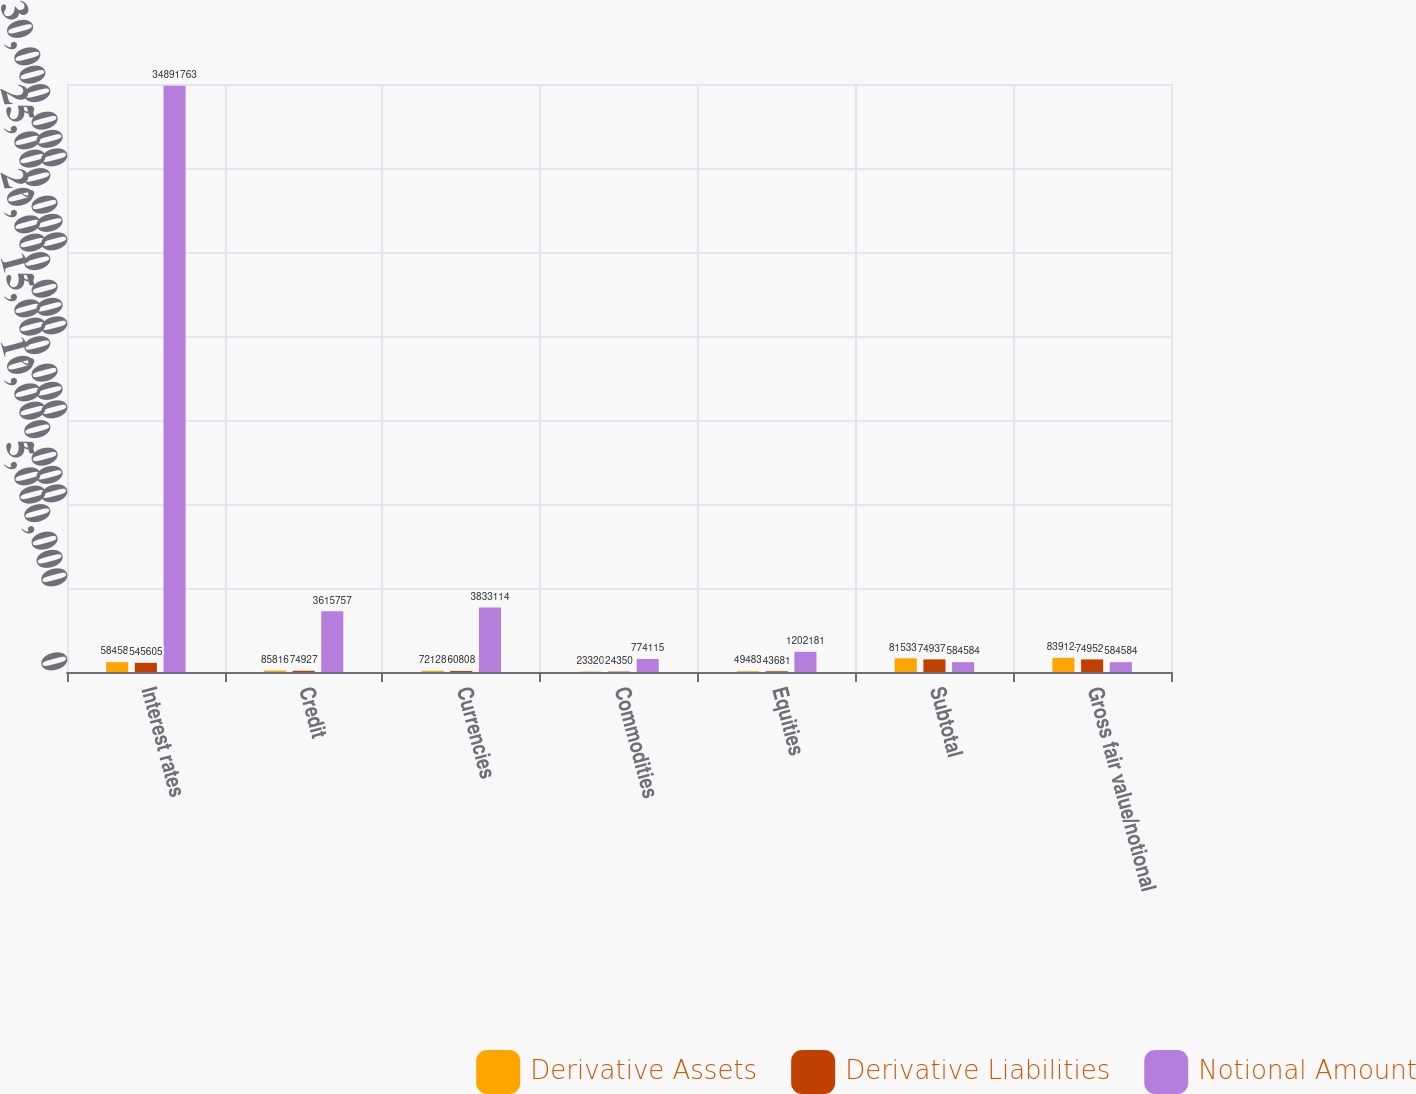Convert chart. <chart><loc_0><loc_0><loc_500><loc_500><stacked_bar_chart><ecel><fcel>Interest rates<fcel>Credit<fcel>Currencies<fcel>Commodities<fcel>Equities<fcel>Subtotal<fcel>Gross fair value/notional<nl><fcel>Derivative Assets<fcel>584584<fcel>85816<fcel>72128<fcel>23320<fcel>49483<fcel>815331<fcel>839124<nl><fcel>Derivative Liabilities<fcel>545605<fcel>74927<fcel>60808<fcel>24350<fcel>43681<fcel>749371<fcel>749523<nl><fcel>Notional Amount<fcel>3.48918e+07<fcel>3.61576e+06<fcel>3.83311e+06<fcel>774115<fcel>1.20218e+06<fcel>584584<fcel>584584<nl></chart> 